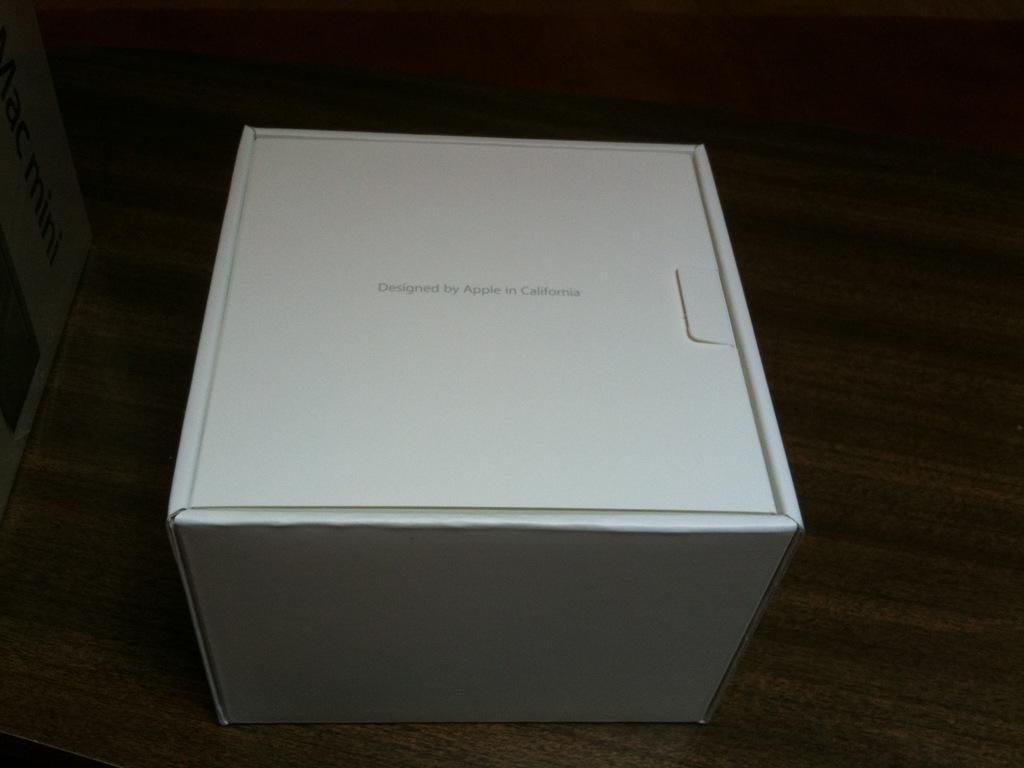Please provide a concise description of this image. In the middle of this image, there is a white color box, on which there is a text. This box is placed on a surface. And the background is dark in color. 